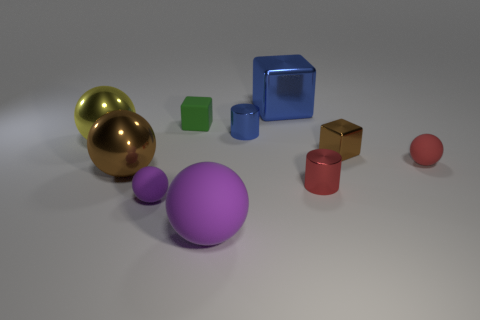How many purple balls must be subtracted to get 1 purple balls? 1 Subtract all blue cubes. How many purple balls are left? 2 Subtract all metallic balls. How many balls are left? 3 Subtract all yellow balls. How many balls are left? 4 Subtract 1 cubes. How many cubes are left? 2 Subtract all gray spheres. Subtract all yellow blocks. How many spheres are left? 5 Add 9 green blocks. How many green blocks are left? 10 Add 5 large metallic blocks. How many large metallic blocks exist? 6 Subtract 0 purple cylinders. How many objects are left? 10 Subtract all cylinders. How many objects are left? 8 